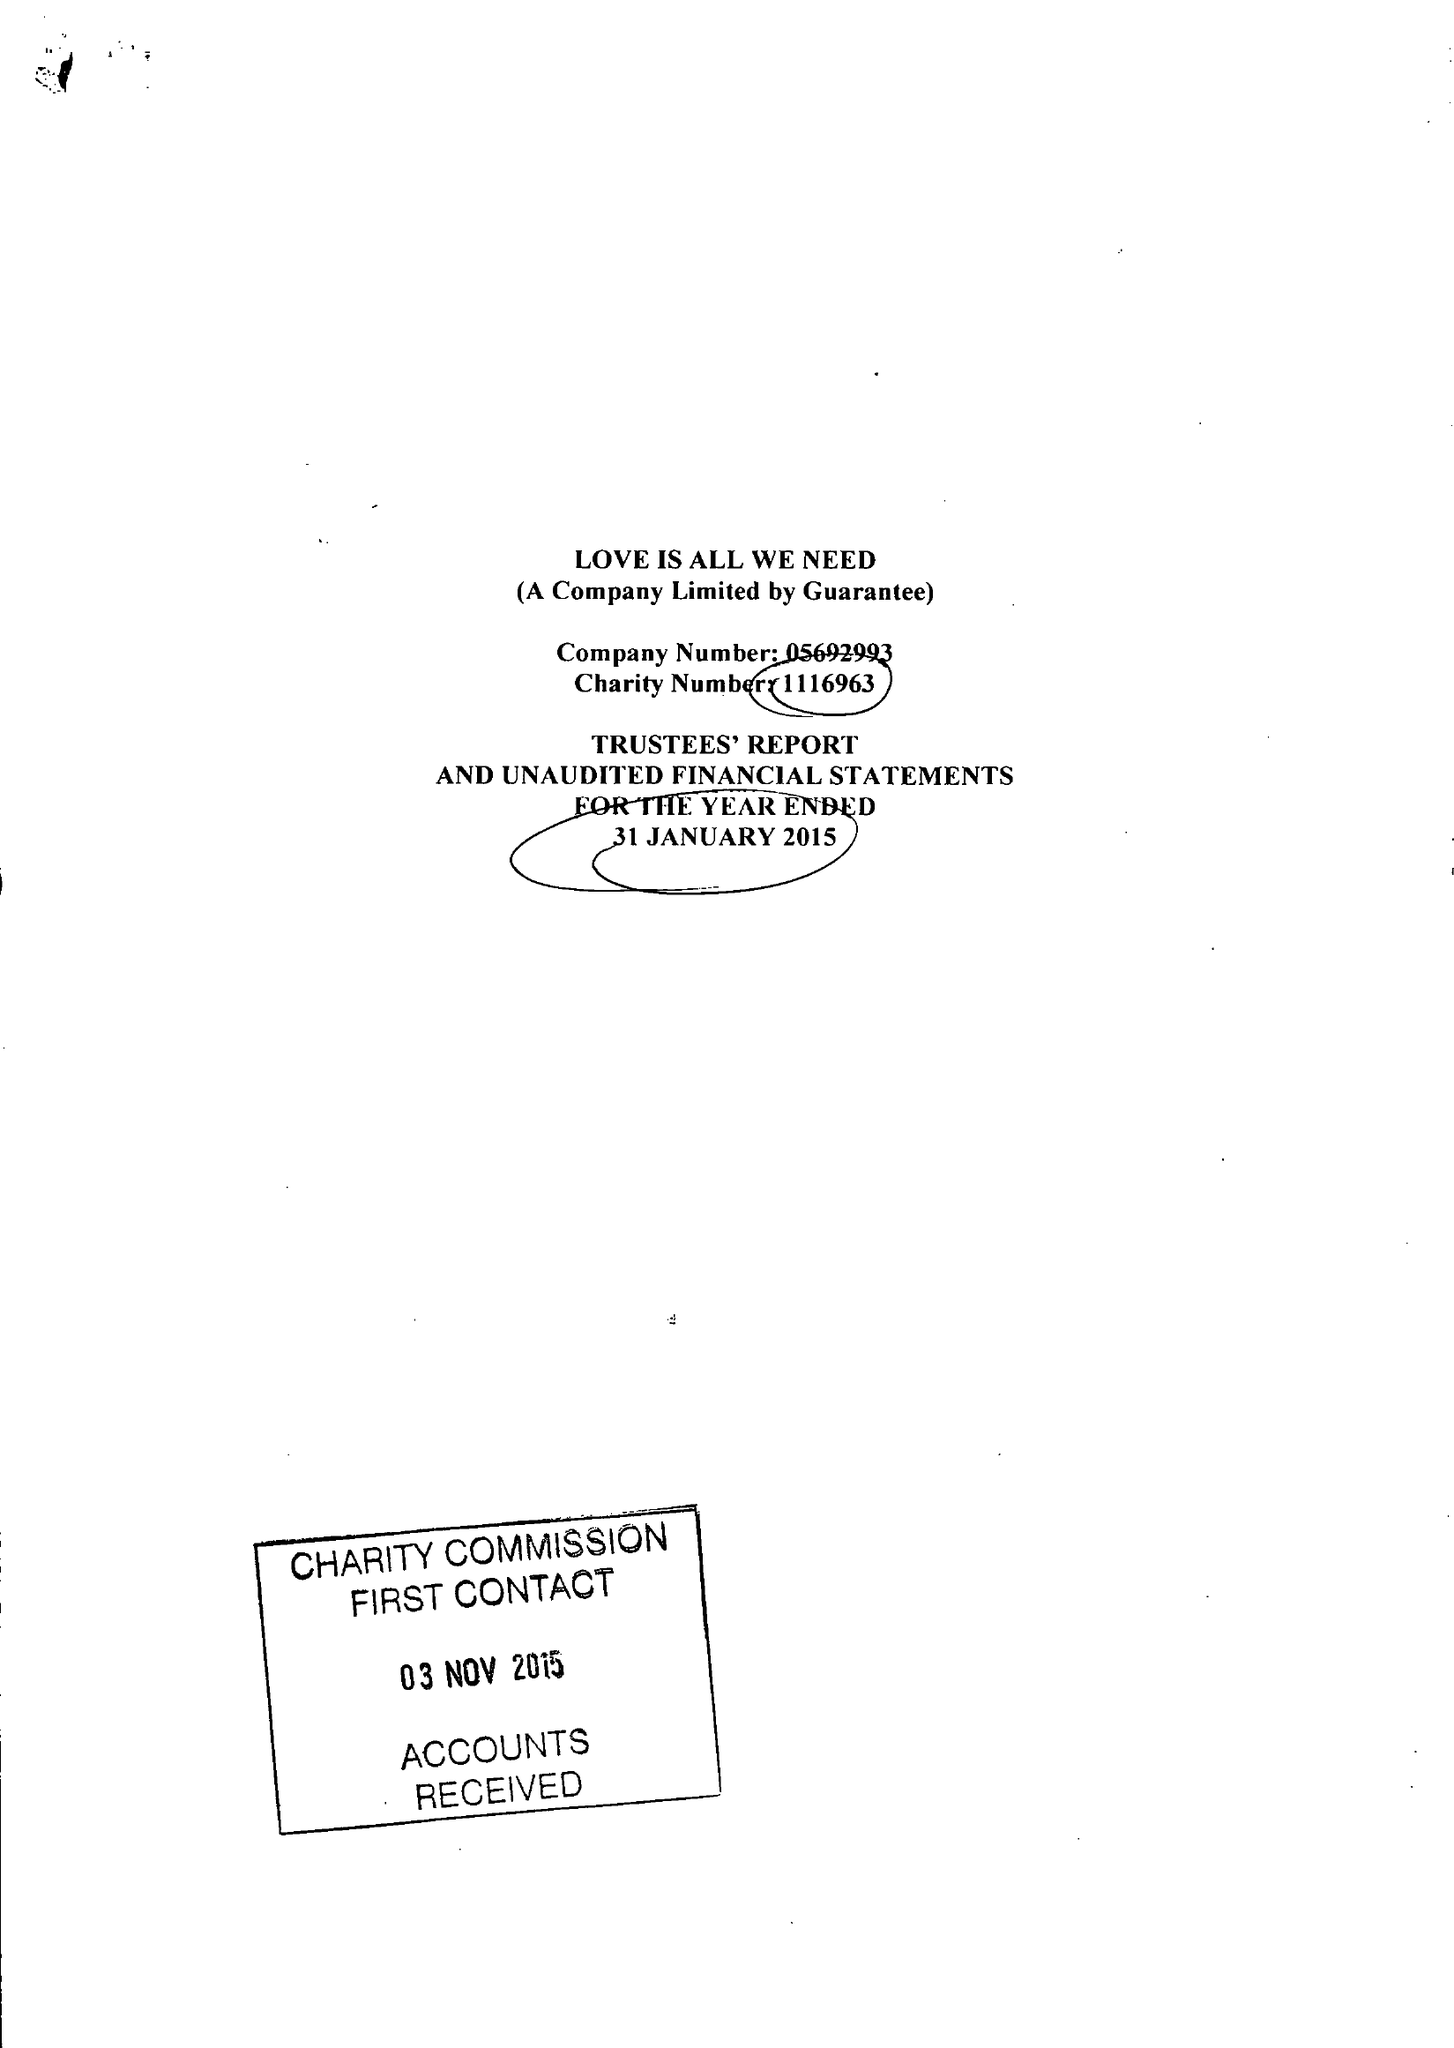What is the value for the charity_number?
Answer the question using a single word or phrase. 1116963 